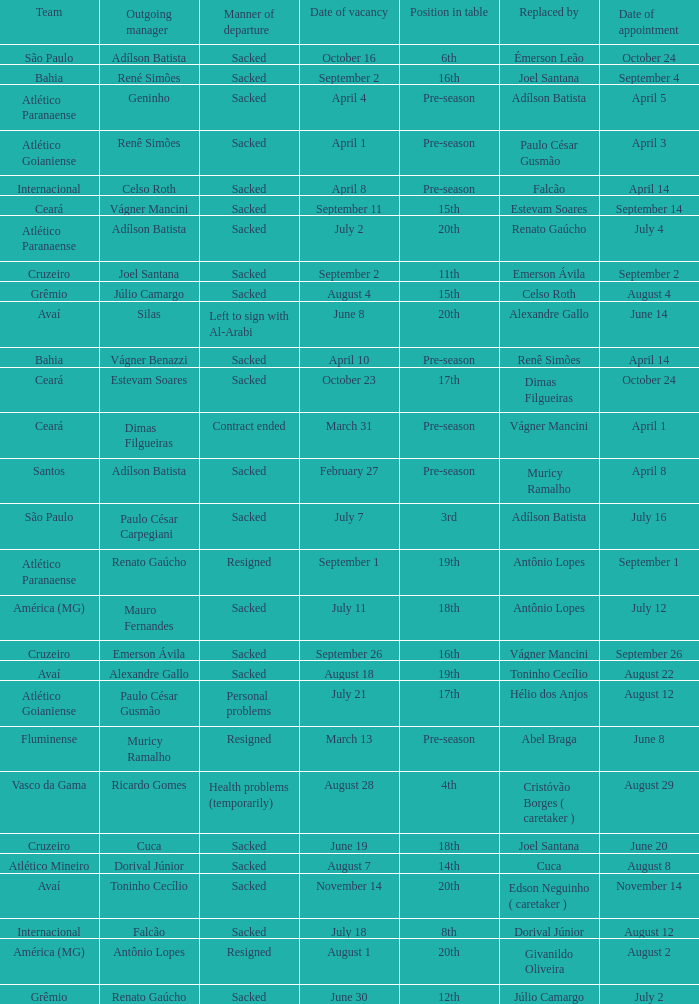Why did Geninho leave as manager? Sacked. 